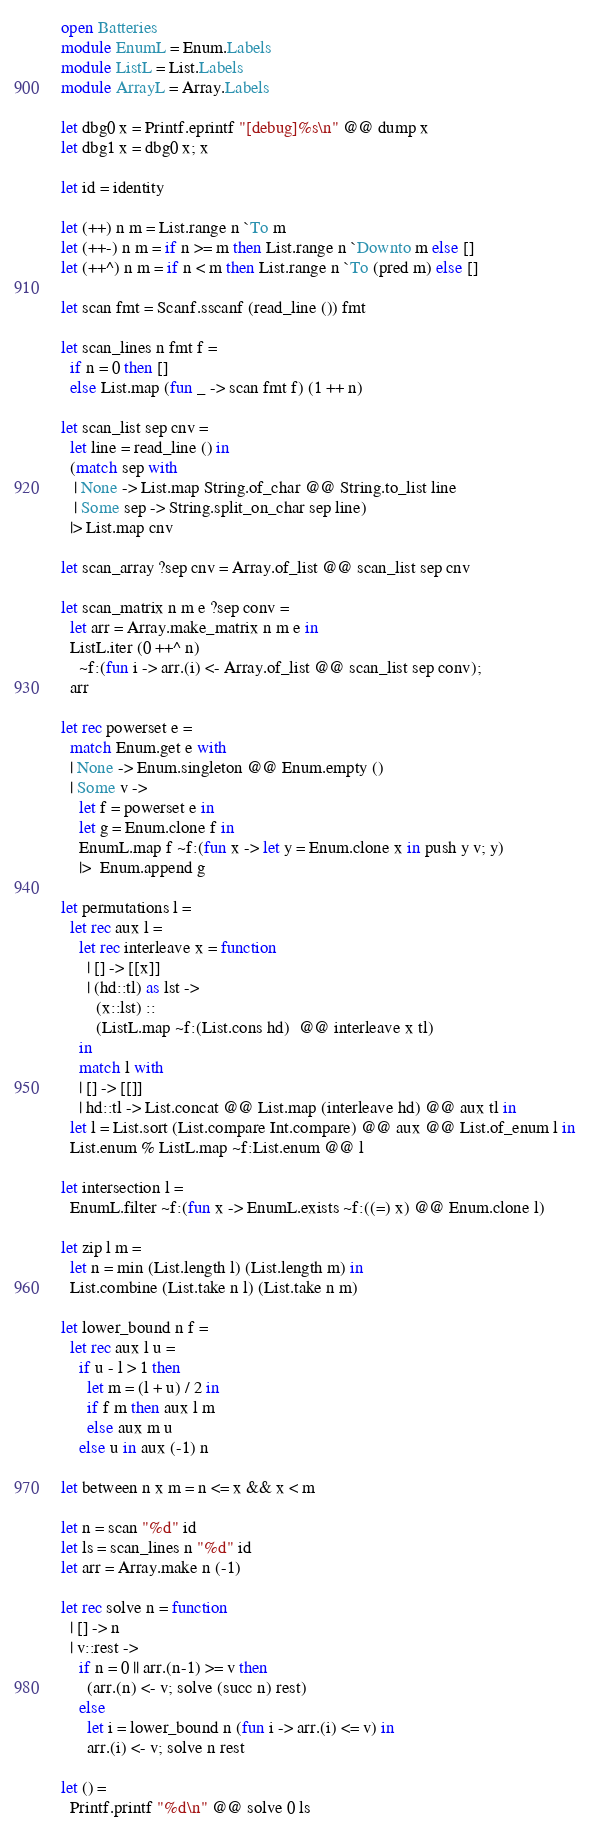<code> <loc_0><loc_0><loc_500><loc_500><_OCaml_>open Batteries
module EnumL = Enum.Labels
module ListL = List.Labels
module ArrayL = Array.Labels

let dbg0 x = Printf.eprintf "[debug]%s\n" @@ dump x
let dbg1 x = dbg0 x; x

let id = identity

let (++) n m = List.range n `To m
let (++-) n m = if n >= m then List.range n `Downto m else []
let (++^) n m = if n < m then List.range n `To (pred m) else []

let scan fmt = Scanf.sscanf (read_line ()) fmt

let scan_lines n fmt f =
  if n = 0 then []
  else List.map (fun _ -> scan fmt f) (1 ++ n)

let scan_list sep cnv =
  let line = read_line () in
  (match sep with
   | None -> List.map String.of_char @@ String.to_list line
   | Some sep -> String.split_on_char sep line)
  |> List.map cnv

let scan_array ?sep cnv = Array.of_list @@ scan_list sep cnv

let scan_matrix n m e ?sep conv =
  let arr = Array.make_matrix n m e in
  ListL.iter (0 ++^ n)
    ~f:(fun i -> arr.(i) <- Array.of_list @@ scan_list sep conv);
  arr

let rec powerset e =
  match Enum.get e with
  | None -> Enum.singleton @@ Enum.empty ()
  | Some v ->
    let f = powerset e in
    let g = Enum.clone f in
    EnumL.map f ~f:(fun x -> let y = Enum.clone x in push y v; y)
    |>  Enum.append g

let permutations l =
  let rec aux l =
    let rec interleave x = function
      | [] -> [[x]]
      | (hd::tl) as lst ->
        (x::lst) ::
        (ListL.map ~f:(List.cons hd)  @@ interleave x tl)
    in
    match l with
    | [] -> [[]]
    | hd::tl -> List.concat @@ List.map (interleave hd) @@ aux tl in
  let l = List.sort (List.compare Int.compare) @@ aux @@ List.of_enum l in
  List.enum % ListL.map ~f:List.enum @@ l

let intersection l =
  EnumL.filter ~f:(fun x -> EnumL.exists ~f:((=) x) @@ Enum.clone l)

let zip l m =
  let n = min (List.length l) (List.length m) in
  List.combine (List.take n l) (List.take n m)

let lower_bound n f =
  let rec aux l u =
    if u - l > 1 then
      let m = (l + u) / 2 in
      if f m then aux l m
      else aux m u
    else u in aux (-1) n

let between n x m = n <= x && x < m

let n = scan "%d" id
let ls = scan_lines n "%d" id
let arr = Array.make n (-1)

let rec solve n = function
  | [] -> n
  | v::rest ->
    if n = 0 || arr.(n-1) >= v then
      (arr.(n) <- v; solve (succ n) rest)
    else
      let i = lower_bound n (fun i -> arr.(i) <= v) in
      arr.(i) <- v; solve n rest

let () =
  Printf.printf "%d\n" @@ solve 0 ls
</code> 